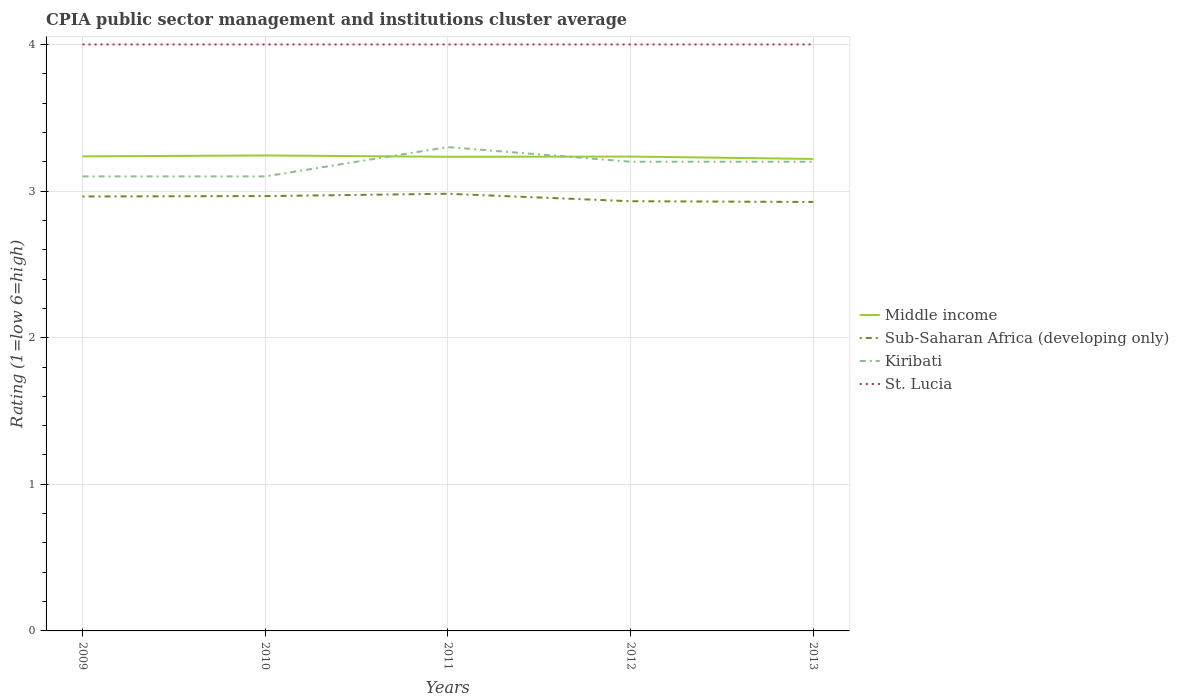Does the line corresponding to Kiribati intersect with the line corresponding to Sub-Saharan Africa (developing only)?
Provide a succinct answer. No. Across all years, what is the maximum CPIA rating in St. Lucia?
Keep it short and to the point. 4. What is the total CPIA rating in Middle income in the graph?
Provide a short and direct response. -0. What is the difference between the highest and the second highest CPIA rating in Middle income?
Your response must be concise. 0.02. How many lines are there?
Make the answer very short. 4. Does the graph contain grids?
Provide a succinct answer. Yes. What is the title of the graph?
Your response must be concise. CPIA public sector management and institutions cluster average. Does "Low income" appear as one of the legend labels in the graph?
Offer a very short reply. No. What is the label or title of the X-axis?
Give a very brief answer. Years. What is the Rating (1=low 6=high) of Middle income in 2009?
Offer a terse response. 3.24. What is the Rating (1=low 6=high) of Sub-Saharan Africa (developing only) in 2009?
Offer a terse response. 2.96. What is the Rating (1=low 6=high) of St. Lucia in 2009?
Ensure brevity in your answer.  4. What is the Rating (1=low 6=high) of Middle income in 2010?
Give a very brief answer. 3.24. What is the Rating (1=low 6=high) in Sub-Saharan Africa (developing only) in 2010?
Your response must be concise. 2.97. What is the Rating (1=low 6=high) of St. Lucia in 2010?
Give a very brief answer. 4. What is the Rating (1=low 6=high) in Middle income in 2011?
Your response must be concise. 3.23. What is the Rating (1=low 6=high) of Sub-Saharan Africa (developing only) in 2011?
Provide a short and direct response. 2.98. What is the Rating (1=low 6=high) of Kiribati in 2011?
Provide a succinct answer. 3.3. What is the Rating (1=low 6=high) in Middle income in 2012?
Provide a succinct answer. 3.24. What is the Rating (1=low 6=high) in Sub-Saharan Africa (developing only) in 2012?
Your answer should be very brief. 2.93. What is the Rating (1=low 6=high) of St. Lucia in 2012?
Your answer should be very brief. 4. What is the Rating (1=low 6=high) of Middle income in 2013?
Your response must be concise. 3.22. What is the Rating (1=low 6=high) in Sub-Saharan Africa (developing only) in 2013?
Offer a terse response. 2.93. Across all years, what is the maximum Rating (1=low 6=high) of Middle income?
Provide a succinct answer. 3.24. Across all years, what is the maximum Rating (1=low 6=high) of Sub-Saharan Africa (developing only)?
Give a very brief answer. 2.98. Across all years, what is the maximum Rating (1=low 6=high) of Kiribati?
Provide a succinct answer. 3.3. Across all years, what is the maximum Rating (1=low 6=high) in St. Lucia?
Your answer should be very brief. 4. Across all years, what is the minimum Rating (1=low 6=high) of Middle income?
Your answer should be compact. 3.22. Across all years, what is the minimum Rating (1=low 6=high) of Sub-Saharan Africa (developing only)?
Your response must be concise. 2.93. Across all years, what is the minimum Rating (1=low 6=high) of Kiribati?
Offer a terse response. 3.1. What is the total Rating (1=low 6=high) of Middle income in the graph?
Ensure brevity in your answer.  16.17. What is the total Rating (1=low 6=high) of Sub-Saharan Africa (developing only) in the graph?
Make the answer very short. 14.77. What is the total Rating (1=low 6=high) in Kiribati in the graph?
Your answer should be very brief. 15.9. What is the difference between the Rating (1=low 6=high) of Middle income in 2009 and that in 2010?
Ensure brevity in your answer.  -0.01. What is the difference between the Rating (1=low 6=high) in Sub-Saharan Africa (developing only) in 2009 and that in 2010?
Make the answer very short. -0. What is the difference between the Rating (1=low 6=high) of Middle income in 2009 and that in 2011?
Offer a very short reply. 0. What is the difference between the Rating (1=low 6=high) of Sub-Saharan Africa (developing only) in 2009 and that in 2011?
Provide a short and direct response. -0.02. What is the difference between the Rating (1=low 6=high) of Kiribati in 2009 and that in 2011?
Keep it short and to the point. -0.2. What is the difference between the Rating (1=low 6=high) of Middle income in 2009 and that in 2012?
Your response must be concise. 0. What is the difference between the Rating (1=low 6=high) of Sub-Saharan Africa (developing only) in 2009 and that in 2012?
Your response must be concise. 0.03. What is the difference between the Rating (1=low 6=high) of St. Lucia in 2009 and that in 2012?
Offer a terse response. 0. What is the difference between the Rating (1=low 6=high) in Middle income in 2009 and that in 2013?
Your answer should be very brief. 0.02. What is the difference between the Rating (1=low 6=high) in Sub-Saharan Africa (developing only) in 2009 and that in 2013?
Give a very brief answer. 0.04. What is the difference between the Rating (1=low 6=high) in Kiribati in 2009 and that in 2013?
Give a very brief answer. -0.1. What is the difference between the Rating (1=low 6=high) in St. Lucia in 2009 and that in 2013?
Your response must be concise. 0. What is the difference between the Rating (1=low 6=high) of Middle income in 2010 and that in 2011?
Provide a short and direct response. 0.01. What is the difference between the Rating (1=low 6=high) of Sub-Saharan Africa (developing only) in 2010 and that in 2011?
Keep it short and to the point. -0.02. What is the difference between the Rating (1=low 6=high) in St. Lucia in 2010 and that in 2011?
Offer a very short reply. 0. What is the difference between the Rating (1=low 6=high) in Middle income in 2010 and that in 2012?
Provide a succinct answer. 0.01. What is the difference between the Rating (1=low 6=high) in Sub-Saharan Africa (developing only) in 2010 and that in 2012?
Make the answer very short. 0.04. What is the difference between the Rating (1=low 6=high) in Middle income in 2010 and that in 2013?
Give a very brief answer. 0.02. What is the difference between the Rating (1=low 6=high) in Sub-Saharan Africa (developing only) in 2010 and that in 2013?
Offer a very short reply. 0.04. What is the difference between the Rating (1=low 6=high) in Middle income in 2011 and that in 2012?
Offer a terse response. -0. What is the difference between the Rating (1=low 6=high) in Sub-Saharan Africa (developing only) in 2011 and that in 2012?
Offer a very short reply. 0.05. What is the difference between the Rating (1=low 6=high) in Kiribati in 2011 and that in 2012?
Keep it short and to the point. 0.1. What is the difference between the Rating (1=low 6=high) in St. Lucia in 2011 and that in 2012?
Give a very brief answer. 0. What is the difference between the Rating (1=low 6=high) in Middle income in 2011 and that in 2013?
Provide a short and direct response. 0.01. What is the difference between the Rating (1=low 6=high) in Sub-Saharan Africa (developing only) in 2011 and that in 2013?
Offer a very short reply. 0.06. What is the difference between the Rating (1=low 6=high) of Middle income in 2012 and that in 2013?
Ensure brevity in your answer.  0.02. What is the difference between the Rating (1=low 6=high) of Sub-Saharan Africa (developing only) in 2012 and that in 2013?
Provide a short and direct response. 0.01. What is the difference between the Rating (1=low 6=high) in Kiribati in 2012 and that in 2013?
Give a very brief answer. 0. What is the difference between the Rating (1=low 6=high) in St. Lucia in 2012 and that in 2013?
Your response must be concise. 0. What is the difference between the Rating (1=low 6=high) in Middle income in 2009 and the Rating (1=low 6=high) in Sub-Saharan Africa (developing only) in 2010?
Offer a very short reply. 0.27. What is the difference between the Rating (1=low 6=high) of Middle income in 2009 and the Rating (1=low 6=high) of Kiribati in 2010?
Provide a short and direct response. 0.14. What is the difference between the Rating (1=low 6=high) in Middle income in 2009 and the Rating (1=low 6=high) in St. Lucia in 2010?
Your answer should be compact. -0.76. What is the difference between the Rating (1=low 6=high) of Sub-Saharan Africa (developing only) in 2009 and the Rating (1=low 6=high) of Kiribati in 2010?
Your response must be concise. -0.14. What is the difference between the Rating (1=low 6=high) in Sub-Saharan Africa (developing only) in 2009 and the Rating (1=low 6=high) in St. Lucia in 2010?
Your answer should be compact. -1.04. What is the difference between the Rating (1=low 6=high) in Middle income in 2009 and the Rating (1=low 6=high) in Sub-Saharan Africa (developing only) in 2011?
Give a very brief answer. 0.26. What is the difference between the Rating (1=low 6=high) of Middle income in 2009 and the Rating (1=low 6=high) of Kiribati in 2011?
Make the answer very short. -0.06. What is the difference between the Rating (1=low 6=high) in Middle income in 2009 and the Rating (1=low 6=high) in St. Lucia in 2011?
Your answer should be compact. -0.76. What is the difference between the Rating (1=low 6=high) in Sub-Saharan Africa (developing only) in 2009 and the Rating (1=low 6=high) in Kiribati in 2011?
Offer a very short reply. -0.34. What is the difference between the Rating (1=low 6=high) in Sub-Saharan Africa (developing only) in 2009 and the Rating (1=low 6=high) in St. Lucia in 2011?
Offer a very short reply. -1.04. What is the difference between the Rating (1=low 6=high) of Kiribati in 2009 and the Rating (1=low 6=high) of St. Lucia in 2011?
Provide a succinct answer. -0.9. What is the difference between the Rating (1=low 6=high) in Middle income in 2009 and the Rating (1=low 6=high) in Sub-Saharan Africa (developing only) in 2012?
Your response must be concise. 0.31. What is the difference between the Rating (1=low 6=high) of Middle income in 2009 and the Rating (1=low 6=high) of Kiribati in 2012?
Offer a very short reply. 0.04. What is the difference between the Rating (1=low 6=high) of Middle income in 2009 and the Rating (1=low 6=high) of St. Lucia in 2012?
Make the answer very short. -0.76. What is the difference between the Rating (1=low 6=high) in Sub-Saharan Africa (developing only) in 2009 and the Rating (1=low 6=high) in Kiribati in 2012?
Provide a short and direct response. -0.24. What is the difference between the Rating (1=low 6=high) in Sub-Saharan Africa (developing only) in 2009 and the Rating (1=low 6=high) in St. Lucia in 2012?
Provide a short and direct response. -1.04. What is the difference between the Rating (1=low 6=high) in Middle income in 2009 and the Rating (1=low 6=high) in Sub-Saharan Africa (developing only) in 2013?
Your answer should be compact. 0.31. What is the difference between the Rating (1=low 6=high) in Middle income in 2009 and the Rating (1=low 6=high) in Kiribati in 2013?
Your answer should be very brief. 0.04. What is the difference between the Rating (1=low 6=high) of Middle income in 2009 and the Rating (1=low 6=high) of St. Lucia in 2013?
Make the answer very short. -0.76. What is the difference between the Rating (1=low 6=high) of Sub-Saharan Africa (developing only) in 2009 and the Rating (1=low 6=high) of Kiribati in 2013?
Offer a terse response. -0.24. What is the difference between the Rating (1=low 6=high) in Sub-Saharan Africa (developing only) in 2009 and the Rating (1=low 6=high) in St. Lucia in 2013?
Your answer should be compact. -1.04. What is the difference between the Rating (1=low 6=high) of Middle income in 2010 and the Rating (1=low 6=high) of Sub-Saharan Africa (developing only) in 2011?
Make the answer very short. 0.26. What is the difference between the Rating (1=low 6=high) of Middle income in 2010 and the Rating (1=low 6=high) of Kiribati in 2011?
Your answer should be very brief. -0.06. What is the difference between the Rating (1=low 6=high) in Middle income in 2010 and the Rating (1=low 6=high) in St. Lucia in 2011?
Make the answer very short. -0.76. What is the difference between the Rating (1=low 6=high) of Sub-Saharan Africa (developing only) in 2010 and the Rating (1=low 6=high) of Kiribati in 2011?
Your response must be concise. -0.33. What is the difference between the Rating (1=low 6=high) in Sub-Saharan Africa (developing only) in 2010 and the Rating (1=low 6=high) in St. Lucia in 2011?
Provide a succinct answer. -1.03. What is the difference between the Rating (1=low 6=high) in Middle income in 2010 and the Rating (1=low 6=high) in Sub-Saharan Africa (developing only) in 2012?
Offer a terse response. 0.31. What is the difference between the Rating (1=low 6=high) of Middle income in 2010 and the Rating (1=low 6=high) of Kiribati in 2012?
Make the answer very short. 0.04. What is the difference between the Rating (1=low 6=high) in Middle income in 2010 and the Rating (1=low 6=high) in St. Lucia in 2012?
Provide a succinct answer. -0.76. What is the difference between the Rating (1=low 6=high) in Sub-Saharan Africa (developing only) in 2010 and the Rating (1=low 6=high) in Kiribati in 2012?
Keep it short and to the point. -0.23. What is the difference between the Rating (1=low 6=high) of Sub-Saharan Africa (developing only) in 2010 and the Rating (1=low 6=high) of St. Lucia in 2012?
Offer a terse response. -1.03. What is the difference between the Rating (1=low 6=high) of Middle income in 2010 and the Rating (1=low 6=high) of Sub-Saharan Africa (developing only) in 2013?
Your answer should be compact. 0.32. What is the difference between the Rating (1=low 6=high) in Middle income in 2010 and the Rating (1=low 6=high) in Kiribati in 2013?
Offer a terse response. 0.04. What is the difference between the Rating (1=low 6=high) of Middle income in 2010 and the Rating (1=low 6=high) of St. Lucia in 2013?
Offer a very short reply. -0.76. What is the difference between the Rating (1=low 6=high) in Sub-Saharan Africa (developing only) in 2010 and the Rating (1=low 6=high) in Kiribati in 2013?
Your answer should be very brief. -0.23. What is the difference between the Rating (1=low 6=high) in Sub-Saharan Africa (developing only) in 2010 and the Rating (1=low 6=high) in St. Lucia in 2013?
Offer a terse response. -1.03. What is the difference between the Rating (1=low 6=high) of Kiribati in 2010 and the Rating (1=low 6=high) of St. Lucia in 2013?
Provide a short and direct response. -0.9. What is the difference between the Rating (1=low 6=high) in Middle income in 2011 and the Rating (1=low 6=high) in Sub-Saharan Africa (developing only) in 2012?
Keep it short and to the point. 0.3. What is the difference between the Rating (1=low 6=high) of Middle income in 2011 and the Rating (1=low 6=high) of Kiribati in 2012?
Keep it short and to the point. 0.03. What is the difference between the Rating (1=low 6=high) in Middle income in 2011 and the Rating (1=low 6=high) in St. Lucia in 2012?
Provide a short and direct response. -0.77. What is the difference between the Rating (1=low 6=high) of Sub-Saharan Africa (developing only) in 2011 and the Rating (1=low 6=high) of Kiribati in 2012?
Make the answer very short. -0.22. What is the difference between the Rating (1=low 6=high) in Sub-Saharan Africa (developing only) in 2011 and the Rating (1=low 6=high) in St. Lucia in 2012?
Offer a terse response. -1.02. What is the difference between the Rating (1=low 6=high) of Middle income in 2011 and the Rating (1=low 6=high) of Sub-Saharan Africa (developing only) in 2013?
Provide a short and direct response. 0.31. What is the difference between the Rating (1=low 6=high) in Middle income in 2011 and the Rating (1=low 6=high) in Kiribati in 2013?
Provide a short and direct response. 0.03. What is the difference between the Rating (1=low 6=high) of Middle income in 2011 and the Rating (1=low 6=high) of St. Lucia in 2013?
Offer a very short reply. -0.77. What is the difference between the Rating (1=low 6=high) in Sub-Saharan Africa (developing only) in 2011 and the Rating (1=low 6=high) in Kiribati in 2013?
Keep it short and to the point. -0.22. What is the difference between the Rating (1=low 6=high) in Sub-Saharan Africa (developing only) in 2011 and the Rating (1=low 6=high) in St. Lucia in 2013?
Give a very brief answer. -1.02. What is the difference between the Rating (1=low 6=high) in Kiribati in 2011 and the Rating (1=low 6=high) in St. Lucia in 2013?
Give a very brief answer. -0.7. What is the difference between the Rating (1=low 6=high) of Middle income in 2012 and the Rating (1=low 6=high) of Sub-Saharan Africa (developing only) in 2013?
Make the answer very short. 0.31. What is the difference between the Rating (1=low 6=high) of Middle income in 2012 and the Rating (1=low 6=high) of Kiribati in 2013?
Provide a short and direct response. 0.04. What is the difference between the Rating (1=low 6=high) in Middle income in 2012 and the Rating (1=low 6=high) in St. Lucia in 2013?
Provide a short and direct response. -0.76. What is the difference between the Rating (1=low 6=high) of Sub-Saharan Africa (developing only) in 2012 and the Rating (1=low 6=high) of Kiribati in 2013?
Give a very brief answer. -0.27. What is the difference between the Rating (1=low 6=high) in Sub-Saharan Africa (developing only) in 2012 and the Rating (1=low 6=high) in St. Lucia in 2013?
Your answer should be very brief. -1.07. What is the difference between the Rating (1=low 6=high) in Kiribati in 2012 and the Rating (1=low 6=high) in St. Lucia in 2013?
Your answer should be very brief. -0.8. What is the average Rating (1=low 6=high) in Middle income per year?
Offer a terse response. 3.23. What is the average Rating (1=low 6=high) in Sub-Saharan Africa (developing only) per year?
Make the answer very short. 2.95. What is the average Rating (1=low 6=high) of Kiribati per year?
Provide a succinct answer. 3.18. What is the average Rating (1=low 6=high) in St. Lucia per year?
Your answer should be very brief. 4. In the year 2009, what is the difference between the Rating (1=low 6=high) in Middle income and Rating (1=low 6=high) in Sub-Saharan Africa (developing only)?
Provide a short and direct response. 0.27. In the year 2009, what is the difference between the Rating (1=low 6=high) of Middle income and Rating (1=low 6=high) of Kiribati?
Make the answer very short. 0.14. In the year 2009, what is the difference between the Rating (1=low 6=high) in Middle income and Rating (1=low 6=high) in St. Lucia?
Your response must be concise. -0.76. In the year 2009, what is the difference between the Rating (1=low 6=high) of Sub-Saharan Africa (developing only) and Rating (1=low 6=high) of Kiribati?
Your answer should be compact. -0.14. In the year 2009, what is the difference between the Rating (1=low 6=high) in Sub-Saharan Africa (developing only) and Rating (1=low 6=high) in St. Lucia?
Your answer should be compact. -1.04. In the year 2010, what is the difference between the Rating (1=low 6=high) in Middle income and Rating (1=low 6=high) in Sub-Saharan Africa (developing only)?
Ensure brevity in your answer.  0.28. In the year 2010, what is the difference between the Rating (1=low 6=high) of Middle income and Rating (1=low 6=high) of Kiribati?
Your answer should be compact. 0.14. In the year 2010, what is the difference between the Rating (1=low 6=high) of Middle income and Rating (1=low 6=high) of St. Lucia?
Offer a very short reply. -0.76. In the year 2010, what is the difference between the Rating (1=low 6=high) in Sub-Saharan Africa (developing only) and Rating (1=low 6=high) in Kiribati?
Keep it short and to the point. -0.13. In the year 2010, what is the difference between the Rating (1=low 6=high) in Sub-Saharan Africa (developing only) and Rating (1=low 6=high) in St. Lucia?
Provide a short and direct response. -1.03. In the year 2010, what is the difference between the Rating (1=low 6=high) in Kiribati and Rating (1=low 6=high) in St. Lucia?
Your answer should be compact. -0.9. In the year 2011, what is the difference between the Rating (1=low 6=high) in Middle income and Rating (1=low 6=high) in Sub-Saharan Africa (developing only)?
Your response must be concise. 0.25. In the year 2011, what is the difference between the Rating (1=low 6=high) of Middle income and Rating (1=low 6=high) of Kiribati?
Offer a very short reply. -0.07. In the year 2011, what is the difference between the Rating (1=low 6=high) in Middle income and Rating (1=low 6=high) in St. Lucia?
Your answer should be very brief. -0.77. In the year 2011, what is the difference between the Rating (1=low 6=high) in Sub-Saharan Africa (developing only) and Rating (1=low 6=high) in Kiribati?
Keep it short and to the point. -0.32. In the year 2011, what is the difference between the Rating (1=low 6=high) in Sub-Saharan Africa (developing only) and Rating (1=low 6=high) in St. Lucia?
Provide a succinct answer. -1.02. In the year 2012, what is the difference between the Rating (1=low 6=high) in Middle income and Rating (1=low 6=high) in Sub-Saharan Africa (developing only)?
Provide a short and direct response. 0.3. In the year 2012, what is the difference between the Rating (1=low 6=high) of Middle income and Rating (1=low 6=high) of Kiribati?
Your answer should be compact. 0.04. In the year 2012, what is the difference between the Rating (1=low 6=high) of Middle income and Rating (1=low 6=high) of St. Lucia?
Make the answer very short. -0.76. In the year 2012, what is the difference between the Rating (1=low 6=high) of Sub-Saharan Africa (developing only) and Rating (1=low 6=high) of Kiribati?
Offer a very short reply. -0.27. In the year 2012, what is the difference between the Rating (1=low 6=high) of Sub-Saharan Africa (developing only) and Rating (1=low 6=high) of St. Lucia?
Make the answer very short. -1.07. In the year 2013, what is the difference between the Rating (1=low 6=high) of Middle income and Rating (1=low 6=high) of Sub-Saharan Africa (developing only)?
Provide a short and direct response. 0.29. In the year 2013, what is the difference between the Rating (1=low 6=high) in Middle income and Rating (1=low 6=high) in Kiribati?
Offer a very short reply. 0.02. In the year 2013, what is the difference between the Rating (1=low 6=high) in Middle income and Rating (1=low 6=high) in St. Lucia?
Ensure brevity in your answer.  -0.78. In the year 2013, what is the difference between the Rating (1=low 6=high) in Sub-Saharan Africa (developing only) and Rating (1=low 6=high) in Kiribati?
Give a very brief answer. -0.27. In the year 2013, what is the difference between the Rating (1=low 6=high) in Sub-Saharan Africa (developing only) and Rating (1=low 6=high) in St. Lucia?
Offer a terse response. -1.07. What is the ratio of the Rating (1=low 6=high) of Middle income in 2009 to that in 2010?
Keep it short and to the point. 1. What is the ratio of the Rating (1=low 6=high) in Kiribati in 2009 to that in 2010?
Offer a very short reply. 1. What is the ratio of the Rating (1=low 6=high) of St. Lucia in 2009 to that in 2010?
Give a very brief answer. 1. What is the ratio of the Rating (1=low 6=high) in Kiribati in 2009 to that in 2011?
Make the answer very short. 0.94. What is the ratio of the Rating (1=low 6=high) of Middle income in 2009 to that in 2012?
Provide a short and direct response. 1. What is the ratio of the Rating (1=low 6=high) of Sub-Saharan Africa (developing only) in 2009 to that in 2012?
Make the answer very short. 1.01. What is the ratio of the Rating (1=low 6=high) in Kiribati in 2009 to that in 2012?
Provide a short and direct response. 0.97. What is the ratio of the Rating (1=low 6=high) of St. Lucia in 2009 to that in 2012?
Your answer should be very brief. 1. What is the ratio of the Rating (1=low 6=high) in Middle income in 2009 to that in 2013?
Your response must be concise. 1.01. What is the ratio of the Rating (1=low 6=high) of Sub-Saharan Africa (developing only) in 2009 to that in 2013?
Keep it short and to the point. 1.01. What is the ratio of the Rating (1=low 6=high) of Kiribati in 2009 to that in 2013?
Provide a short and direct response. 0.97. What is the ratio of the Rating (1=low 6=high) of St. Lucia in 2009 to that in 2013?
Your answer should be compact. 1. What is the ratio of the Rating (1=low 6=high) in Middle income in 2010 to that in 2011?
Make the answer very short. 1. What is the ratio of the Rating (1=low 6=high) of Kiribati in 2010 to that in 2011?
Offer a terse response. 0.94. What is the ratio of the Rating (1=low 6=high) of St. Lucia in 2010 to that in 2011?
Your answer should be very brief. 1. What is the ratio of the Rating (1=low 6=high) in Middle income in 2010 to that in 2012?
Provide a succinct answer. 1. What is the ratio of the Rating (1=low 6=high) of Sub-Saharan Africa (developing only) in 2010 to that in 2012?
Offer a terse response. 1.01. What is the ratio of the Rating (1=low 6=high) in Kiribati in 2010 to that in 2012?
Your response must be concise. 0.97. What is the ratio of the Rating (1=low 6=high) of Middle income in 2010 to that in 2013?
Your response must be concise. 1.01. What is the ratio of the Rating (1=low 6=high) of Sub-Saharan Africa (developing only) in 2010 to that in 2013?
Keep it short and to the point. 1.01. What is the ratio of the Rating (1=low 6=high) in Kiribati in 2010 to that in 2013?
Give a very brief answer. 0.97. What is the ratio of the Rating (1=low 6=high) of Sub-Saharan Africa (developing only) in 2011 to that in 2012?
Ensure brevity in your answer.  1.02. What is the ratio of the Rating (1=low 6=high) of Kiribati in 2011 to that in 2012?
Offer a terse response. 1.03. What is the ratio of the Rating (1=low 6=high) in Middle income in 2011 to that in 2013?
Offer a terse response. 1. What is the ratio of the Rating (1=low 6=high) in Sub-Saharan Africa (developing only) in 2011 to that in 2013?
Your response must be concise. 1.02. What is the ratio of the Rating (1=low 6=high) of Kiribati in 2011 to that in 2013?
Provide a short and direct response. 1.03. What is the ratio of the Rating (1=low 6=high) of Sub-Saharan Africa (developing only) in 2012 to that in 2013?
Keep it short and to the point. 1. What is the ratio of the Rating (1=low 6=high) of Kiribati in 2012 to that in 2013?
Keep it short and to the point. 1. What is the ratio of the Rating (1=low 6=high) of St. Lucia in 2012 to that in 2013?
Your response must be concise. 1. What is the difference between the highest and the second highest Rating (1=low 6=high) in Middle income?
Your answer should be very brief. 0.01. What is the difference between the highest and the second highest Rating (1=low 6=high) in Sub-Saharan Africa (developing only)?
Provide a short and direct response. 0.02. What is the difference between the highest and the second highest Rating (1=low 6=high) of Kiribati?
Offer a terse response. 0.1. What is the difference between the highest and the lowest Rating (1=low 6=high) of Middle income?
Keep it short and to the point. 0.02. What is the difference between the highest and the lowest Rating (1=low 6=high) of Sub-Saharan Africa (developing only)?
Provide a succinct answer. 0.06. What is the difference between the highest and the lowest Rating (1=low 6=high) in St. Lucia?
Your answer should be very brief. 0. 